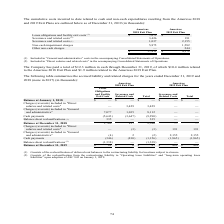According to Sykes Enterprises Incorporated's financial document, How much has the Company paid in total in 2019? a total of $12.3 million in cash through December 31, 2019, of which $10.4 million related to the Americas 2018 Exit Plan and $1.9 million related to the Americas 2019 Exit Plan.. The document states: "The Company has paid a total of $12.3 million in cash through December 31, 2019, of which $10.4 million related to the Americas 2018 Exit Plan and $1...." Also, Where are the Severance and related costs included in the accompanying Consolidated Statements of Operations? The document shows two values: General and administrative and Direct salaries and related costs. From the document: "(1) Included in “General and administrative” costs in the accompanying Consolidated Statements of Operations. (2) Included in “Direct salaries idated ..." Also, For which years is the Americas Exit Plan accounted for? The document shows two values: 2019 and 2018. From the document: "expenditures resulting from the Americas 2018 and 2019 Exit Plans are outlined below as of December 31, 2019 (in thousands): non-cash expenditures res..." Additionally, In which year was Non-cash impairment charges larger? According to the financial document, 2018. The relevant text states: "non-cash expenditures resulting from the Americas 2018 and 2019 Exit Plans are outlined below as of December 31, 2019 (in thousands):..." Also, can you calculate: What was the change in non-cash impairment charges in 2019 from 2018? Based on the calculation: 1,582-5,875, the result is -4293 (in thousands). This is based on the information: "Non-cash impairment charges 5,875 1,582 Non-cash impairment charges 5,875 1,582..." The key data points involved are: 1,582, 5,875. Also, can you calculate: What was the percentage change in non-cash impairment charges in 2019 from 2018? To answer this question, I need to perform calculations using the financial data. The calculation is: (1,582-5,875)/5,875, which equals -73.07 (percentage). This is based on the information: "Non-cash impairment charges 5,875 1,582 Non-cash impairment charges 5,875 1,582..." The key data points involved are: 1,582, 5,875. 